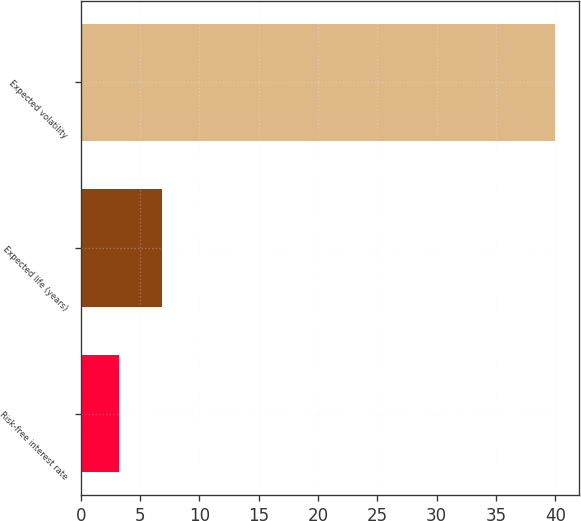<chart> <loc_0><loc_0><loc_500><loc_500><bar_chart><fcel>Risk-free interest rate<fcel>Expected life (years)<fcel>Expected volatility<nl><fcel>3.2<fcel>6.88<fcel>40<nl></chart> 